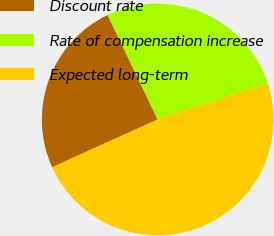<chart> <loc_0><loc_0><loc_500><loc_500><pie_chart><fcel>Discount rate<fcel>Rate of compensation increase<fcel>Expected long-term<nl><fcel>24.66%<fcel>27.06%<fcel>48.28%<nl></chart> 